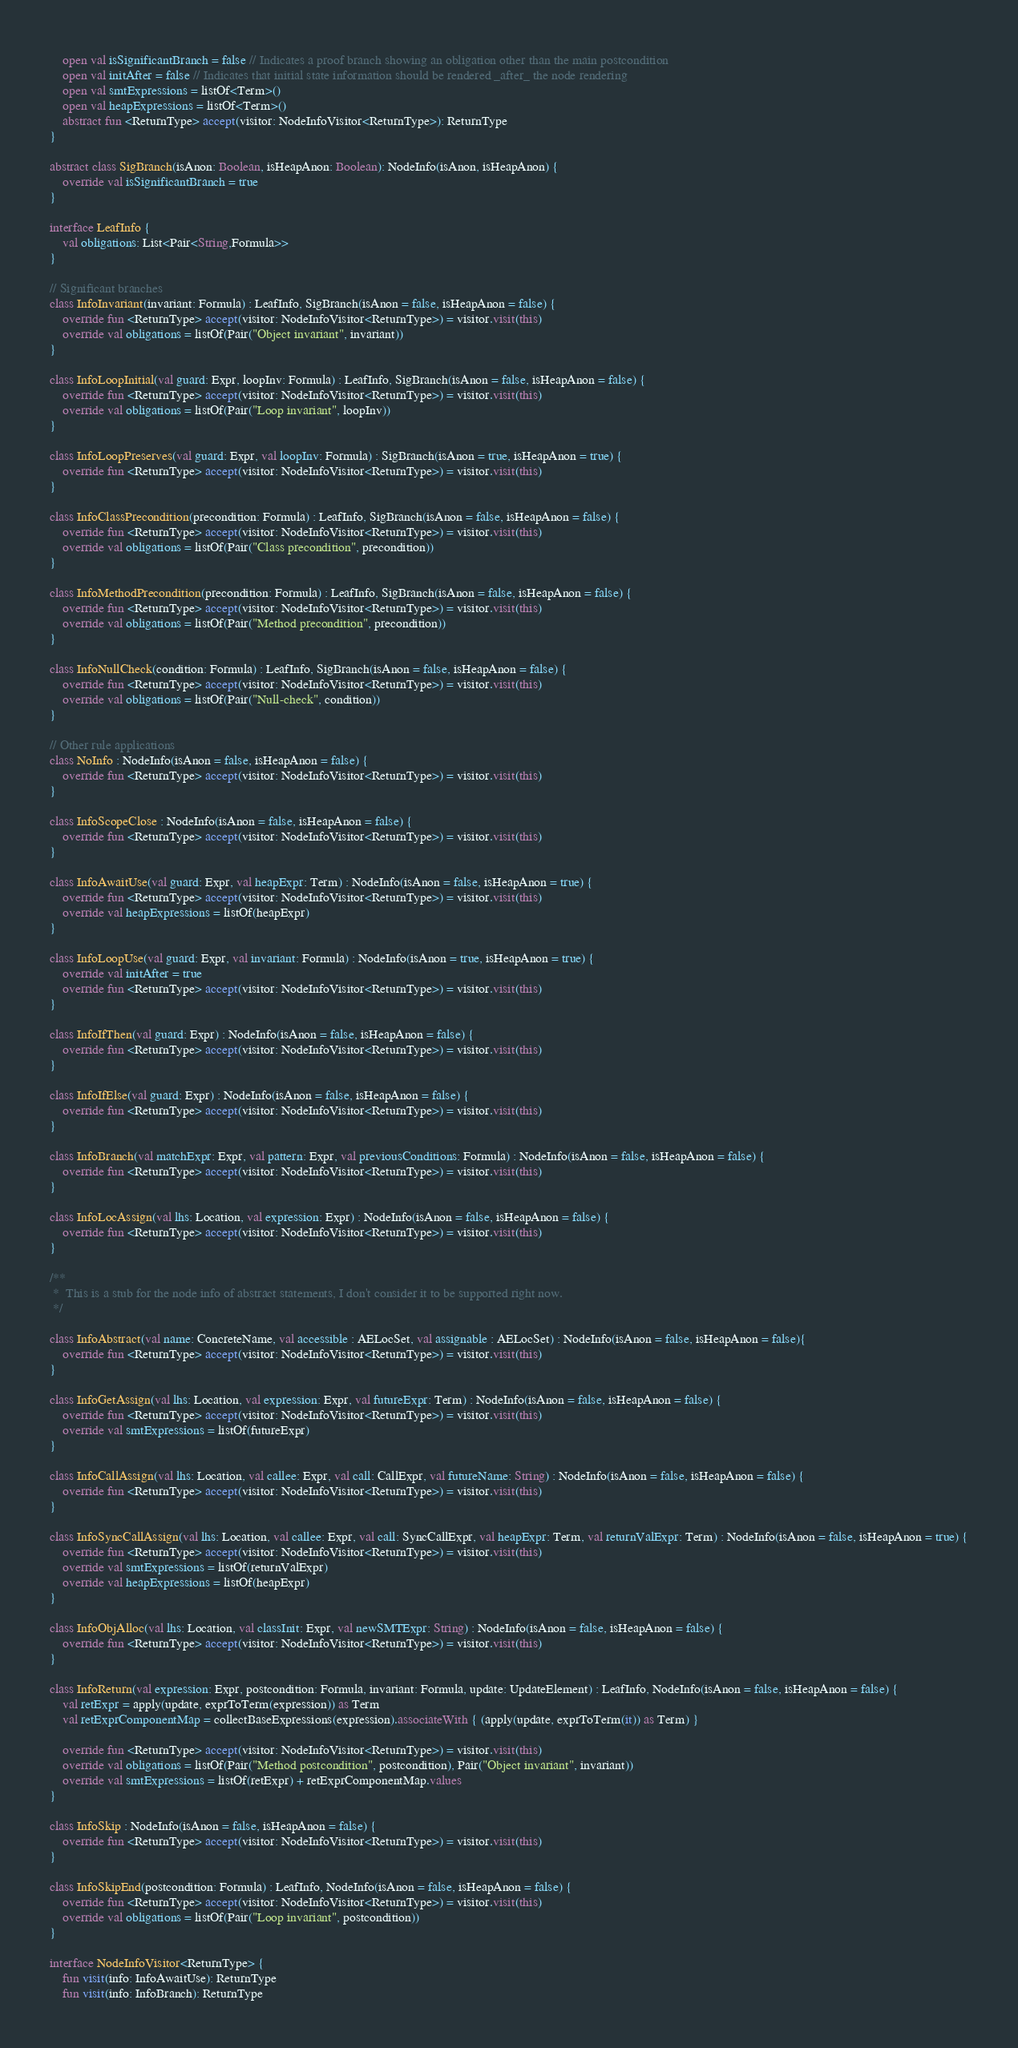<code> <loc_0><loc_0><loc_500><loc_500><_Kotlin_>	open val isSignificantBranch = false // Indicates a proof branch showing an obligation other than the main postcondition
	open val initAfter = false // Indicates that initial state information should be rendered _after_ the node rendering
	open val smtExpressions = listOf<Term>()
	open val heapExpressions = listOf<Term>()
	abstract fun <ReturnType> accept(visitor: NodeInfoVisitor<ReturnType>): ReturnType
}

abstract class SigBranch(isAnon: Boolean, isHeapAnon: Boolean): NodeInfo(isAnon, isHeapAnon) {
	override val isSignificantBranch = true
}

interface LeafInfo {
	val obligations: List<Pair<String,Formula>>
}

// Significant branches
class InfoInvariant(invariant: Formula) : LeafInfo, SigBranch(isAnon = false, isHeapAnon = false) {
	override fun <ReturnType> accept(visitor: NodeInfoVisitor<ReturnType>) = visitor.visit(this)
	override val obligations = listOf(Pair("Object invariant", invariant))
}

class InfoLoopInitial(val guard: Expr, loopInv: Formula) : LeafInfo, SigBranch(isAnon = false, isHeapAnon = false) {
	override fun <ReturnType> accept(visitor: NodeInfoVisitor<ReturnType>) = visitor.visit(this)
	override val obligations = listOf(Pair("Loop invariant", loopInv))
}

class InfoLoopPreserves(val guard: Expr, val loopInv: Formula) : SigBranch(isAnon = true, isHeapAnon = true) {
	override fun <ReturnType> accept(visitor: NodeInfoVisitor<ReturnType>) = visitor.visit(this)
}

class InfoClassPrecondition(precondition: Formula) : LeafInfo, SigBranch(isAnon = false, isHeapAnon = false) {
	override fun <ReturnType> accept(visitor: NodeInfoVisitor<ReturnType>) = visitor.visit(this)
	override val obligations = listOf(Pair("Class precondition", precondition))
}

class InfoMethodPrecondition(precondition: Formula) : LeafInfo, SigBranch(isAnon = false, isHeapAnon = false) {
	override fun <ReturnType> accept(visitor: NodeInfoVisitor<ReturnType>) = visitor.visit(this)
	override val obligations = listOf(Pair("Method precondition", precondition))
}

class InfoNullCheck(condition: Formula) : LeafInfo, SigBranch(isAnon = false, isHeapAnon = false) {
	override fun <ReturnType> accept(visitor: NodeInfoVisitor<ReturnType>) = visitor.visit(this)
	override val obligations = listOf(Pair("Null-check", condition))
}

// Other rule applications
class NoInfo : NodeInfo(isAnon = false, isHeapAnon = false) {
	override fun <ReturnType> accept(visitor: NodeInfoVisitor<ReturnType>) = visitor.visit(this)
}

class InfoScopeClose : NodeInfo(isAnon = false, isHeapAnon = false) {
	override fun <ReturnType> accept(visitor: NodeInfoVisitor<ReturnType>) = visitor.visit(this)
}

class InfoAwaitUse(val guard: Expr, val heapExpr: Term) : NodeInfo(isAnon = false, isHeapAnon = true) {
	override fun <ReturnType> accept(visitor: NodeInfoVisitor<ReturnType>) = visitor.visit(this)
	override val heapExpressions = listOf(heapExpr)
}

class InfoLoopUse(val guard: Expr, val invariant: Formula) : NodeInfo(isAnon = true, isHeapAnon = true) {
	override val initAfter = true
	override fun <ReturnType> accept(visitor: NodeInfoVisitor<ReturnType>) = visitor.visit(this)
}

class InfoIfThen(val guard: Expr) : NodeInfo(isAnon = false, isHeapAnon = false) {
	override fun <ReturnType> accept(visitor: NodeInfoVisitor<ReturnType>) = visitor.visit(this)
}

class InfoIfElse(val guard: Expr) : NodeInfo(isAnon = false, isHeapAnon = false) {
	override fun <ReturnType> accept(visitor: NodeInfoVisitor<ReturnType>) = visitor.visit(this)
}

class InfoBranch(val matchExpr: Expr, val pattern: Expr, val previousConditions: Formula) : NodeInfo(isAnon = false, isHeapAnon = false) {
	override fun <ReturnType> accept(visitor: NodeInfoVisitor<ReturnType>) = visitor.visit(this)
}

class InfoLocAssign(val lhs: Location, val expression: Expr) : NodeInfo(isAnon = false, isHeapAnon = false) {
	override fun <ReturnType> accept(visitor: NodeInfoVisitor<ReturnType>) = visitor.visit(this)
}

/**
 * 	This is a stub for the node info of abstract statements, I don't consider it to be supported right now.
 */

class InfoAbstract(val name: ConcreteName, val accessible : AELocSet, val assignable : AELocSet) : NodeInfo(isAnon = false, isHeapAnon = false){
	override fun <ReturnType> accept(visitor: NodeInfoVisitor<ReturnType>) = visitor.visit(this)
}

class InfoGetAssign(val lhs: Location, val expression: Expr, val futureExpr: Term) : NodeInfo(isAnon = false, isHeapAnon = false) {
	override fun <ReturnType> accept(visitor: NodeInfoVisitor<ReturnType>) = visitor.visit(this)
	override val smtExpressions = listOf(futureExpr)
}

class InfoCallAssign(val lhs: Location, val callee: Expr, val call: CallExpr, val futureName: String) : NodeInfo(isAnon = false, isHeapAnon = false) {
	override fun <ReturnType> accept(visitor: NodeInfoVisitor<ReturnType>) = visitor.visit(this)
}

class InfoSyncCallAssign(val lhs: Location, val callee: Expr, val call: SyncCallExpr, val heapExpr: Term, val returnValExpr: Term) : NodeInfo(isAnon = false, isHeapAnon = true) {
	override fun <ReturnType> accept(visitor: NodeInfoVisitor<ReturnType>) = visitor.visit(this)
	override val smtExpressions = listOf(returnValExpr)
	override val heapExpressions = listOf(heapExpr)
}

class InfoObjAlloc(val lhs: Location, val classInit: Expr, val newSMTExpr: String) : NodeInfo(isAnon = false, isHeapAnon = false) {
	override fun <ReturnType> accept(visitor: NodeInfoVisitor<ReturnType>) = visitor.visit(this)
}

class InfoReturn(val expression: Expr, postcondition: Formula, invariant: Formula, update: UpdateElement) : LeafInfo, NodeInfo(isAnon = false, isHeapAnon = false) {
	val retExpr = apply(update, exprToTerm(expression)) as Term
	val retExprComponentMap = collectBaseExpressions(expression).associateWith { (apply(update, exprToTerm(it)) as Term) }
	
	override fun <ReturnType> accept(visitor: NodeInfoVisitor<ReturnType>) = visitor.visit(this)
	override val obligations = listOf(Pair("Method postcondition", postcondition), Pair("Object invariant", invariant))
	override val smtExpressions = listOf(retExpr) + retExprComponentMap.values
}

class InfoSkip : NodeInfo(isAnon = false, isHeapAnon = false) {
	override fun <ReturnType> accept(visitor: NodeInfoVisitor<ReturnType>) = visitor.visit(this)
}

class InfoSkipEnd(postcondition: Formula) : LeafInfo, NodeInfo(isAnon = false, isHeapAnon = false) {
	override fun <ReturnType> accept(visitor: NodeInfoVisitor<ReturnType>) = visitor.visit(this)
	override val obligations = listOf(Pair("Loop invariant", postcondition))
}

interface NodeInfoVisitor<ReturnType> {
    fun visit(info: InfoAwaitUse): ReturnType
    fun visit(info: InfoBranch): ReturnType</code> 